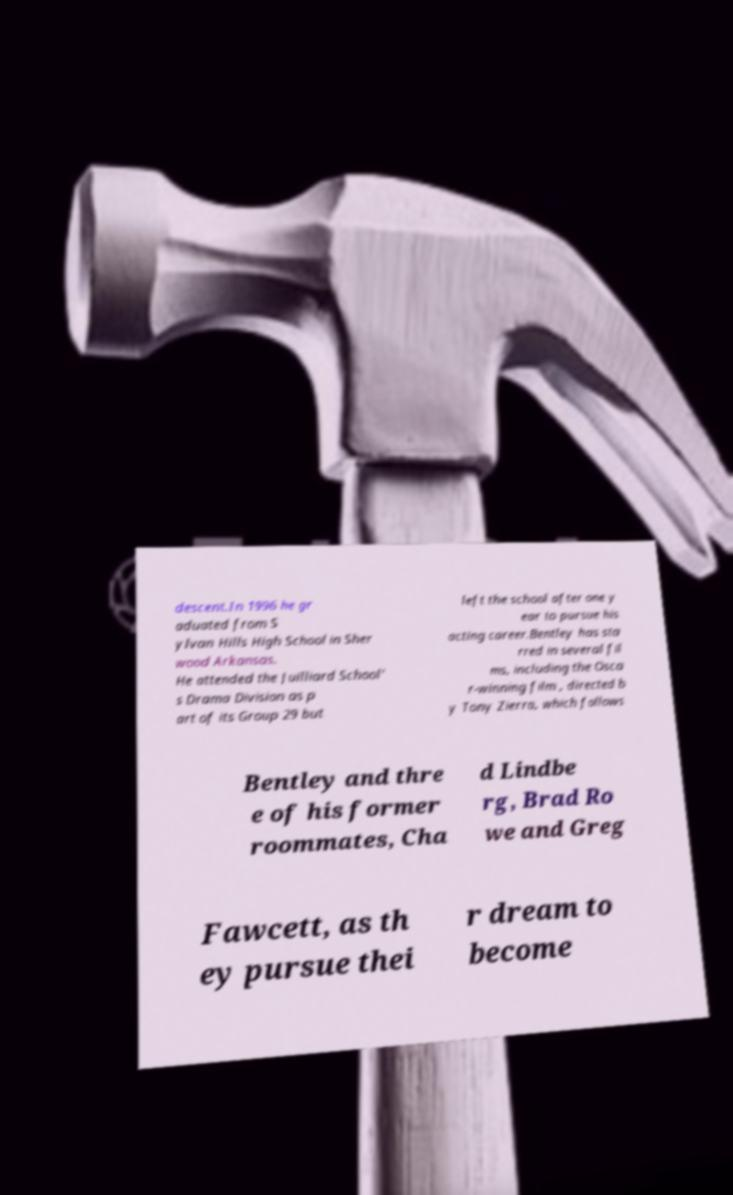Could you assist in decoding the text presented in this image and type it out clearly? descent.In 1996 he gr aduated from S ylvan Hills High School in Sher wood Arkansas. He attended the Juilliard School' s Drama Division as p art of its Group 29 but left the school after one y ear to pursue his acting career.Bentley has sta rred in several fil ms, including the Osca r-winning film , directed b y Tony Zierra, which follows Bentley and thre e of his former roommates, Cha d Lindbe rg, Brad Ro we and Greg Fawcett, as th ey pursue thei r dream to become 